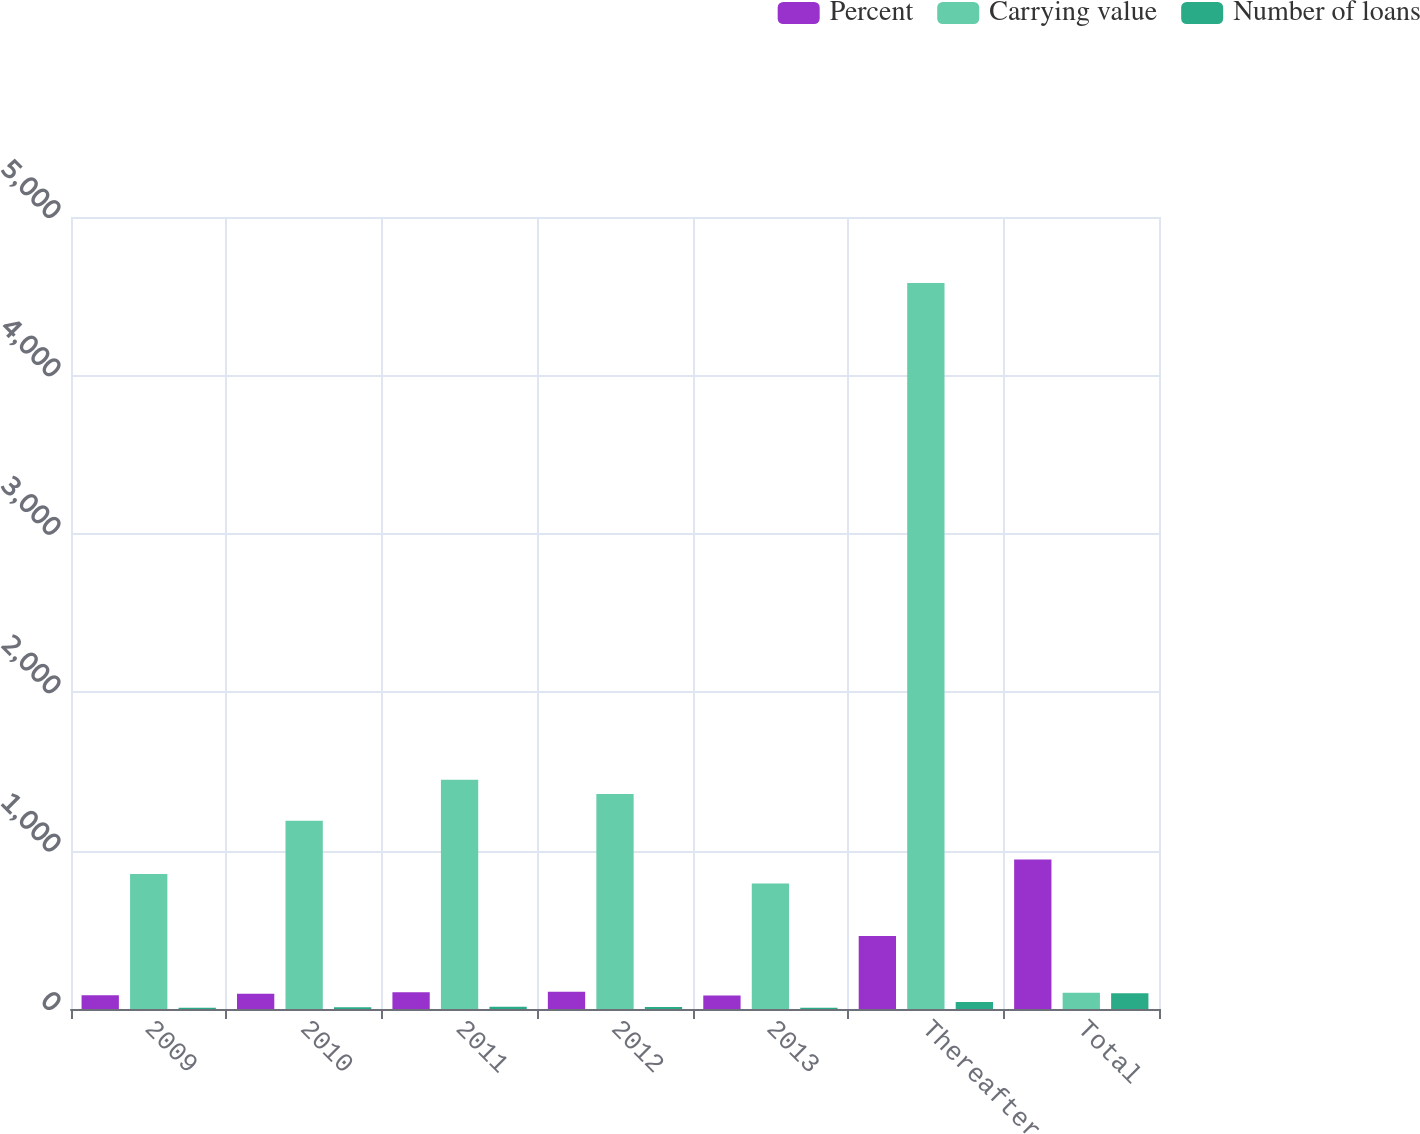<chart> <loc_0><loc_0><loc_500><loc_500><stacked_bar_chart><ecel><fcel>2009<fcel>2010<fcel>2011<fcel>2012<fcel>2013<fcel>Thereafter<fcel>Total<nl><fcel>Percent<fcel>87<fcel>96<fcel>106<fcel>109<fcel>85<fcel>461<fcel>944<nl><fcel>Carrying value<fcel>853<fcel>1189<fcel>1447<fcel>1358<fcel>793<fcel>4584<fcel>103<nl><fcel>Number of loans<fcel>8.3<fcel>11.6<fcel>14.2<fcel>13.3<fcel>7.8<fcel>44.8<fcel>100<nl></chart> 